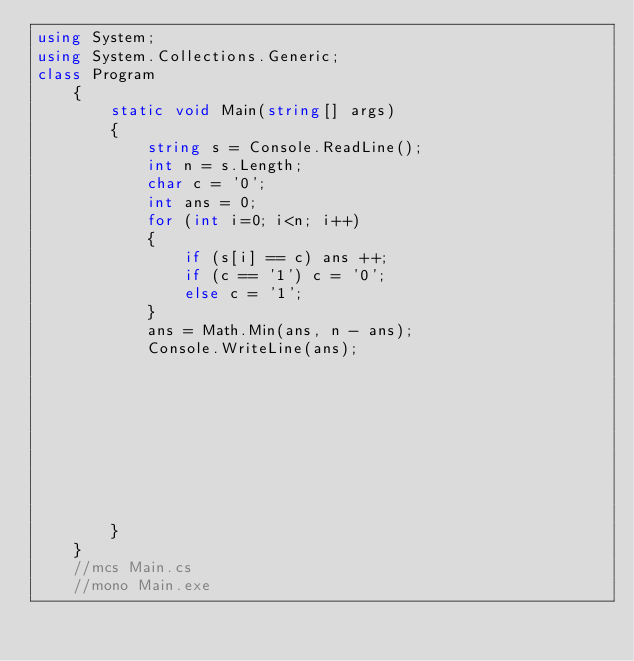Convert code to text. <code><loc_0><loc_0><loc_500><loc_500><_C#_>using System;
using System.Collections.Generic;
class Program
    {
        static void Main(string[] args)
        {
            string s = Console.ReadLine();
            int n = s.Length;
            char c = '0';
            int ans = 0;
            for (int i=0; i<n; i++)
            {
                if (s[i] == c) ans ++;
                if (c == '1') c = '0';
                else c = '1'; 
            }
            ans = Math.Min(ans, n - ans);
            Console.WriteLine(ans);

            
            

            
            


            
        }
    }
    //mcs Main.cs
    //mono Main.exe</code> 